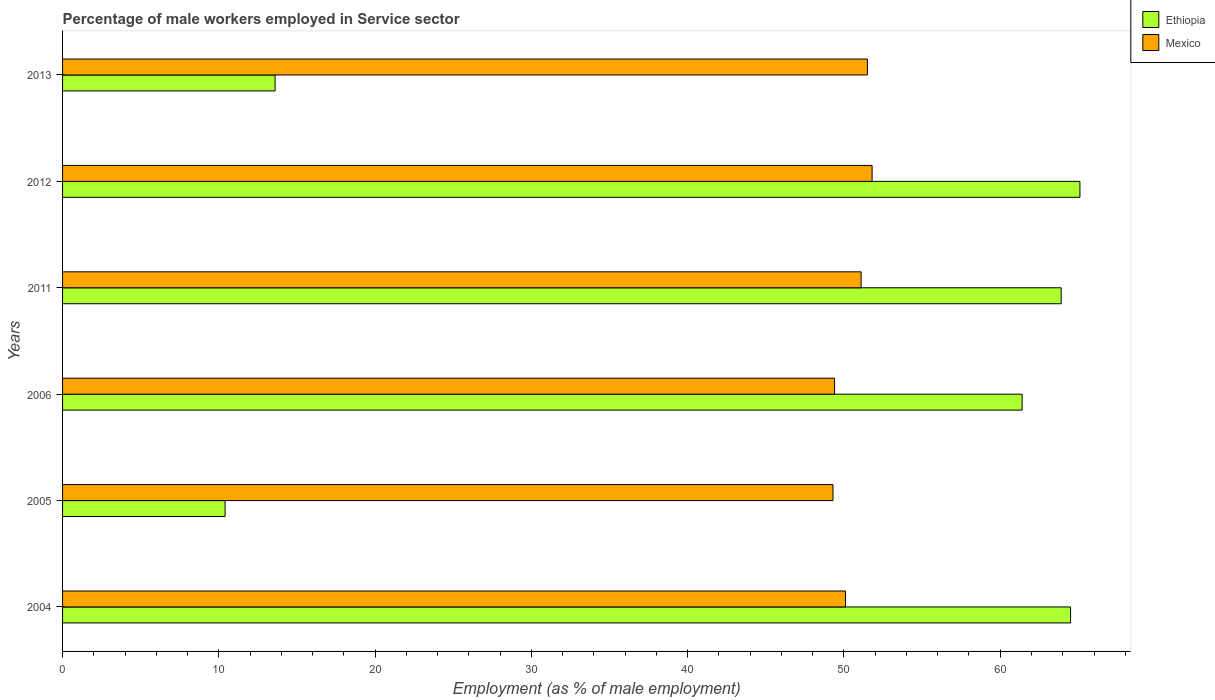How many groups of bars are there?
Ensure brevity in your answer.  6. How many bars are there on the 1st tick from the top?
Your answer should be compact. 2. How many bars are there on the 2nd tick from the bottom?
Ensure brevity in your answer.  2. In how many cases, is the number of bars for a given year not equal to the number of legend labels?
Provide a short and direct response. 0. What is the percentage of male workers employed in Service sector in Ethiopia in 2006?
Keep it short and to the point. 61.4. Across all years, what is the maximum percentage of male workers employed in Service sector in Mexico?
Make the answer very short. 51.8. Across all years, what is the minimum percentage of male workers employed in Service sector in Ethiopia?
Offer a terse response. 10.4. In which year was the percentage of male workers employed in Service sector in Mexico maximum?
Make the answer very short. 2012. What is the total percentage of male workers employed in Service sector in Ethiopia in the graph?
Provide a short and direct response. 278.9. What is the difference between the percentage of male workers employed in Service sector in Ethiopia in 2012 and that in 2013?
Ensure brevity in your answer.  51.5. What is the difference between the percentage of male workers employed in Service sector in Mexico in 2005 and the percentage of male workers employed in Service sector in Ethiopia in 2012?
Keep it short and to the point. -15.8. What is the average percentage of male workers employed in Service sector in Mexico per year?
Your answer should be very brief. 50.53. In the year 2013, what is the difference between the percentage of male workers employed in Service sector in Ethiopia and percentage of male workers employed in Service sector in Mexico?
Provide a succinct answer. -37.9. What is the ratio of the percentage of male workers employed in Service sector in Mexico in 2004 to that in 2006?
Give a very brief answer. 1.01. Is the difference between the percentage of male workers employed in Service sector in Ethiopia in 2005 and 2012 greater than the difference between the percentage of male workers employed in Service sector in Mexico in 2005 and 2012?
Your response must be concise. No. What is the difference between the highest and the second highest percentage of male workers employed in Service sector in Mexico?
Provide a short and direct response. 0.3. What is the difference between the highest and the lowest percentage of male workers employed in Service sector in Ethiopia?
Your answer should be very brief. 54.7. In how many years, is the percentage of male workers employed in Service sector in Ethiopia greater than the average percentage of male workers employed in Service sector in Ethiopia taken over all years?
Provide a short and direct response. 4. What does the 1st bar from the top in 2006 represents?
Keep it short and to the point. Mexico. What does the 2nd bar from the bottom in 2013 represents?
Your answer should be very brief. Mexico. How many bars are there?
Your answer should be compact. 12. Are all the bars in the graph horizontal?
Offer a very short reply. Yes. Are the values on the major ticks of X-axis written in scientific E-notation?
Offer a very short reply. No. Does the graph contain grids?
Your answer should be very brief. No. Where does the legend appear in the graph?
Provide a succinct answer. Top right. What is the title of the graph?
Provide a succinct answer. Percentage of male workers employed in Service sector. What is the label or title of the X-axis?
Provide a short and direct response. Employment (as % of male employment). What is the Employment (as % of male employment) of Ethiopia in 2004?
Keep it short and to the point. 64.5. What is the Employment (as % of male employment) of Mexico in 2004?
Provide a short and direct response. 50.1. What is the Employment (as % of male employment) of Ethiopia in 2005?
Your response must be concise. 10.4. What is the Employment (as % of male employment) of Mexico in 2005?
Your answer should be compact. 49.3. What is the Employment (as % of male employment) in Ethiopia in 2006?
Your response must be concise. 61.4. What is the Employment (as % of male employment) of Mexico in 2006?
Your answer should be very brief. 49.4. What is the Employment (as % of male employment) of Ethiopia in 2011?
Offer a very short reply. 63.9. What is the Employment (as % of male employment) of Mexico in 2011?
Give a very brief answer. 51.1. What is the Employment (as % of male employment) in Ethiopia in 2012?
Give a very brief answer. 65.1. What is the Employment (as % of male employment) in Mexico in 2012?
Offer a terse response. 51.8. What is the Employment (as % of male employment) of Ethiopia in 2013?
Give a very brief answer. 13.6. What is the Employment (as % of male employment) in Mexico in 2013?
Make the answer very short. 51.5. Across all years, what is the maximum Employment (as % of male employment) of Ethiopia?
Your response must be concise. 65.1. Across all years, what is the maximum Employment (as % of male employment) of Mexico?
Ensure brevity in your answer.  51.8. Across all years, what is the minimum Employment (as % of male employment) of Ethiopia?
Your answer should be very brief. 10.4. Across all years, what is the minimum Employment (as % of male employment) of Mexico?
Provide a succinct answer. 49.3. What is the total Employment (as % of male employment) in Ethiopia in the graph?
Ensure brevity in your answer.  278.9. What is the total Employment (as % of male employment) of Mexico in the graph?
Ensure brevity in your answer.  303.2. What is the difference between the Employment (as % of male employment) of Ethiopia in 2004 and that in 2005?
Give a very brief answer. 54.1. What is the difference between the Employment (as % of male employment) of Mexico in 2004 and that in 2005?
Your response must be concise. 0.8. What is the difference between the Employment (as % of male employment) in Ethiopia in 2004 and that in 2006?
Make the answer very short. 3.1. What is the difference between the Employment (as % of male employment) of Mexico in 2004 and that in 2006?
Provide a succinct answer. 0.7. What is the difference between the Employment (as % of male employment) in Ethiopia in 2004 and that in 2011?
Offer a terse response. 0.6. What is the difference between the Employment (as % of male employment) of Mexico in 2004 and that in 2011?
Offer a terse response. -1. What is the difference between the Employment (as % of male employment) in Ethiopia in 2004 and that in 2012?
Give a very brief answer. -0.6. What is the difference between the Employment (as % of male employment) of Mexico in 2004 and that in 2012?
Your answer should be very brief. -1.7. What is the difference between the Employment (as % of male employment) in Ethiopia in 2004 and that in 2013?
Offer a very short reply. 50.9. What is the difference between the Employment (as % of male employment) of Mexico in 2004 and that in 2013?
Give a very brief answer. -1.4. What is the difference between the Employment (as % of male employment) in Ethiopia in 2005 and that in 2006?
Offer a terse response. -51. What is the difference between the Employment (as % of male employment) in Mexico in 2005 and that in 2006?
Ensure brevity in your answer.  -0.1. What is the difference between the Employment (as % of male employment) in Ethiopia in 2005 and that in 2011?
Offer a terse response. -53.5. What is the difference between the Employment (as % of male employment) of Ethiopia in 2005 and that in 2012?
Ensure brevity in your answer.  -54.7. What is the difference between the Employment (as % of male employment) in Ethiopia in 2005 and that in 2013?
Make the answer very short. -3.2. What is the difference between the Employment (as % of male employment) of Ethiopia in 2006 and that in 2011?
Give a very brief answer. -2.5. What is the difference between the Employment (as % of male employment) in Mexico in 2006 and that in 2011?
Offer a very short reply. -1.7. What is the difference between the Employment (as % of male employment) in Ethiopia in 2006 and that in 2012?
Keep it short and to the point. -3.7. What is the difference between the Employment (as % of male employment) of Ethiopia in 2006 and that in 2013?
Offer a terse response. 47.8. What is the difference between the Employment (as % of male employment) of Ethiopia in 2011 and that in 2012?
Your answer should be compact. -1.2. What is the difference between the Employment (as % of male employment) of Mexico in 2011 and that in 2012?
Keep it short and to the point. -0.7. What is the difference between the Employment (as % of male employment) in Ethiopia in 2011 and that in 2013?
Offer a terse response. 50.3. What is the difference between the Employment (as % of male employment) in Mexico in 2011 and that in 2013?
Your answer should be compact. -0.4. What is the difference between the Employment (as % of male employment) in Ethiopia in 2012 and that in 2013?
Ensure brevity in your answer.  51.5. What is the difference between the Employment (as % of male employment) of Mexico in 2012 and that in 2013?
Provide a short and direct response. 0.3. What is the difference between the Employment (as % of male employment) of Ethiopia in 2004 and the Employment (as % of male employment) of Mexico in 2011?
Provide a short and direct response. 13.4. What is the difference between the Employment (as % of male employment) in Ethiopia in 2005 and the Employment (as % of male employment) in Mexico in 2006?
Your response must be concise. -39. What is the difference between the Employment (as % of male employment) in Ethiopia in 2005 and the Employment (as % of male employment) in Mexico in 2011?
Ensure brevity in your answer.  -40.7. What is the difference between the Employment (as % of male employment) of Ethiopia in 2005 and the Employment (as % of male employment) of Mexico in 2012?
Your response must be concise. -41.4. What is the difference between the Employment (as % of male employment) of Ethiopia in 2005 and the Employment (as % of male employment) of Mexico in 2013?
Your answer should be very brief. -41.1. What is the difference between the Employment (as % of male employment) of Ethiopia in 2006 and the Employment (as % of male employment) of Mexico in 2012?
Provide a succinct answer. 9.6. What is the average Employment (as % of male employment) of Ethiopia per year?
Your response must be concise. 46.48. What is the average Employment (as % of male employment) of Mexico per year?
Your answer should be very brief. 50.53. In the year 2005, what is the difference between the Employment (as % of male employment) of Ethiopia and Employment (as % of male employment) of Mexico?
Ensure brevity in your answer.  -38.9. In the year 2013, what is the difference between the Employment (as % of male employment) in Ethiopia and Employment (as % of male employment) in Mexico?
Keep it short and to the point. -37.9. What is the ratio of the Employment (as % of male employment) of Ethiopia in 2004 to that in 2005?
Offer a very short reply. 6.2. What is the ratio of the Employment (as % of male employment) in Mexico in 2004 to that in 2005?
Give a very brief answer. 1.02. What is the ratio of the Employment (as % of male employment) in Ethiopia in 2004 to that in 2006?
Your answer should be compact. 1.05. What is the ratio of the Employment (as % of male employment) of Mexico in 2004 to that in 2006?
Keep it short and to the point. 1.01. What is the ratio of the Employment (as % of male employment) in Ethiopia in 2004 to that in 2011?
Keep it short and to the point. 1.01. What is the ratio of the Employment (as % of male employment) in Mexico in 2004 to that in 2011?
Your response must be concise. 0.98. What is the ratio of the Employment (as % of male employment) in Mexico in 2004 to that in 2012?
Give a very brief answer. 0.97. What is the ratio of the Employment (as % of male employment) in Ethiopia in 2004 to that in 2013?
Keep it short and to the point. 4.74. What is the ratio of the Employment (as % of male employment) of Mexico in 2004 to that in 2013?
Your answer should be very brief. 0.97. What is the ratio of the Employment (as % of male employment) of Ethiopia in 2005 to that in 2006?
Offer a very short reply. 0.17. What is the ratio of the Employment (as % of male employment) of Ethiopia in 2005 to that in 2011?
Your answer should be compact. 0.16. What is the ratio of the Employment (as % of male employment) of Mexico in 2005 to that in 2011?
Provide a short and direct response. 0.96. What is the ratio of the Employment (as % of male employment) of Ethiopia in 2005 to that in 2012?
Your response must be concise. 0.16. What is the ratio of the Employment (as % of male employment) in Mexico in 2005 to that in 2012?
Provide a succinct answer. 0.95. What is the ratio of the Employment (as % of male employment) of Ethiopia in 2005 to that in 2013?
Give a very brief answer. 0.76. What is the ratio of the Employment (as % of male employment) of Mexico in 2005 to that in 2013?
Offer a very short reply. 0.96. What is the ratio of the Employment (as % of male employment) of Ethiopia in 2006 to that in 2011?
Your answer should be compact. 0.96. What is the ratio of the Employment (as % of male employment) of Mexico in 2006 to that in 2011?
Offer a very short reply. 0.97. What is the ratio of the Employment (as % of male employment) in Ethiopia in 2006 to that in 2012?
Your answer should be very brief. 0.94. What is the ratio of the Employment (as % of male employment) of Mexico in 2006 to that in 2012?
Your answer should be compact. 0.95. What is the ratio of the Employment (as % of male employment) of Ethiopia in 2006 to that in 2013?
Offer a terse response. 4.51. What is the ratio of the Employment (as % of male employment) of Mexico in 2006 to that in 2013?
Provide a succinct answer. 0.96. What is the ratio of the Employment (as % of male employment) in Ethiopia in 2011 to that in 2012?
Provide a succinct answer. 0.98. What is the ratio of the Employment (as % of male employment) of Mexico in 2011 to that in 2012?
Offer a terse response. 0.99. What is the ratio of the Employment (as % of male employment) in Ethiopia in 2011 to that in 2013?
Keep it short and to the point. 4.7. What is the ratio of the Employment (as % of male employment) of Mexico in 2011 to that in 2013?
Provide a short and direct response. 0.99. What is the ratio of the Employment (as % of male employment) of Ethiopia in 2012 to that in 2013?
Your answer should be very brief. 4.79. What is the difference between the highest and the lowest Employment (as % of male employment) in Ethiopia?
Your answer should be very brief. 54.7. 